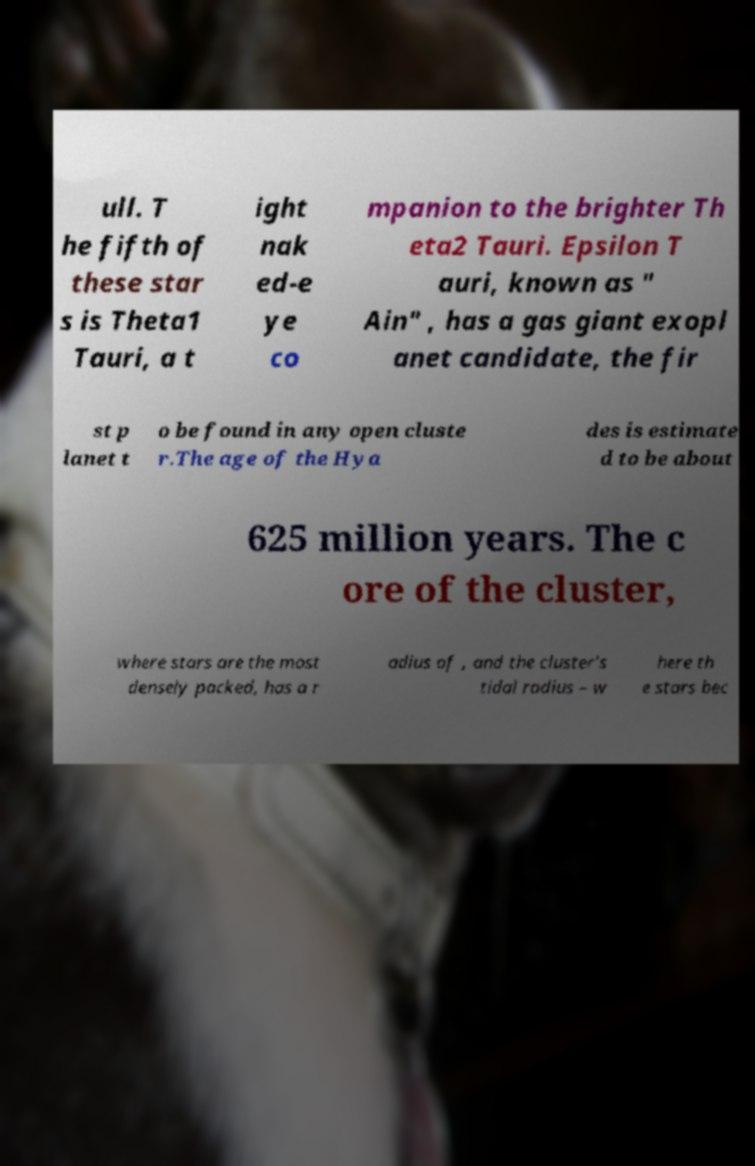I need the written content from this picture converted into text. Can you do that? ull. T he fifth of these star s is Theta1 Tauri, a t ight nak ed-e ye co mpanion to the brighter Th eta2 Tauri. Epsilon T auri, known as " Ain" , has a gas giant exopl anet candidate, the fir st p lanet t o be found in any open cluste r.The age of the Hya des is estimate d to be about 625 million years. The c ore of the cluster, where stars are the most densely packed, has a r adius of , and the cluster's tidal radius – w here th e stars bec 